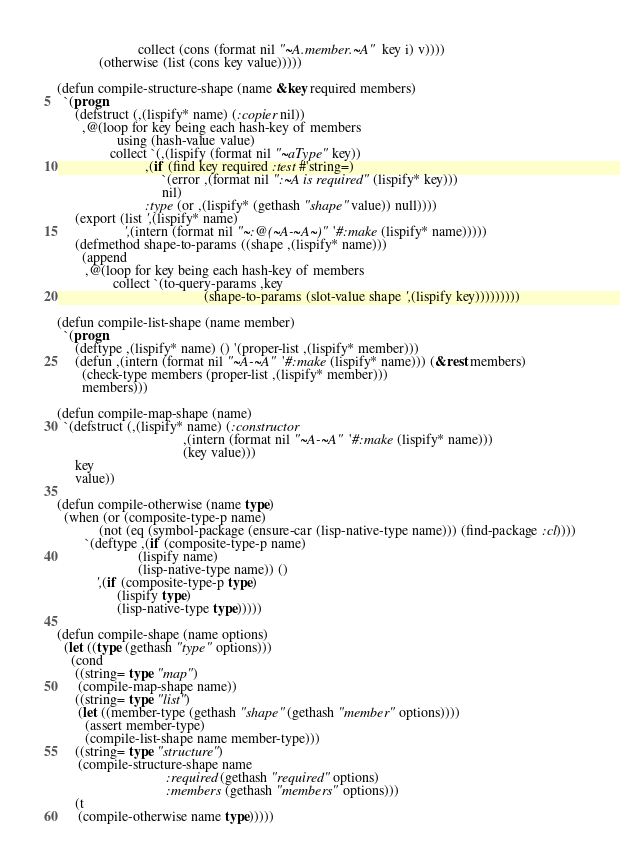Convert code to text. <code><loc_0><loc_0><loc_500><loc_500><_Lisp_>                       collect (cons (format nil "~A.member.~A" key i) v))))
            (otherwise (list (cons key value)))))

(defun compile-structure-shape (name &key required members)
  `(progn
     (defstruct (,(lispify* name) (:copier nil))
       ,@(loop for key being each hash-key of members
                 using (hash-value value)
               collect `(,(lispify (format nil "~aType" key))
                         ,(if (find key required :test #'string=)
                              `(error ,(format nil ":~A is required" (lispify* key)))
                              nil)
                         :type (or ,(lispify* (gethash "shape" value)) null))))
     (export (list ',(lispify* name)
                   ',(intern (format nil "~:@(~A-~A~)" '#:make (lispify* name)))))
     (defmethod shape-to-params ((shape ,(lispify* name)))
       (append
        ,@(loop for key being each hash-key of members
                collect `(to-query-params ,key
                                          (shape-to-params (slot-value shape ',(lispify key)))))))))

(defun compile-list-shape (name member)
  `(progn
     (deftype ,(lispify* name) () '(proper-list ,(lispify* member)))
     (defun ,(intern (format nil "~A-~A" '#:make (lispify* name))) (&rest members)
       (check-type members (proper-list ,(lispify* member)))
       members)))

(defun compile-map-shape (name)
  `(defstruct (,(lispify* name) (:constructor
                                    ,(intern (format nil "~A-~A" '#:make (lispify* name)))
                                    (key value)))
     key
     value))

(defun compile-otherwise (name type)
  (when (or (composite-type-p name)
            (not (eq (symbol-package (ensure-car (lisp-native-type name))) (find-package :cl))))
        `(deftype ,(if (composite-type-p name)
                       (lispify name)
                       (lisp-native-type name)) ()
           ',(if (composite-type-p type)
                 (lispify type)
                 (lisp-native-type type)))))

(defun compile-shape (name options)
  (let ((type (gethash "type" options)))
    (cond
     ((string= type "map")
      (compile-map-shape name))
     ((string= type "list")
      (let ((member-type (gethash "shape" (gethash "member" options))))
        (assert member-type)
        (compile-list-shape name member-type)))
     ((string= type "structure")
      (compile-structure-shape name
                               :required (gethash "required" options)
                               :members (gethash "members" options)))
     (t
      (compile-otherwise name type)))))
</code> 